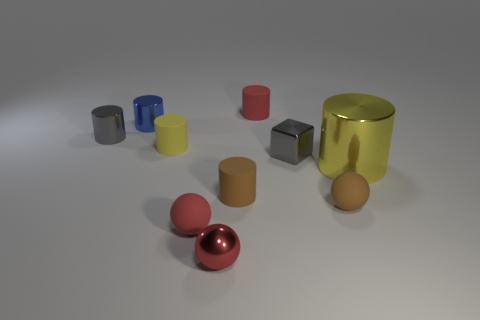Can you describe the textures and colors present in this collection of objects? The objects displayed in the image showcase a variety of textures and colors. Some objects have a shiny, metallic finish, reflecting light and providing a sense of smoothness. These include the red ball and the tiny ball next to it, as well as the yellow cylinder. Others, like the blue cylinder, exhibit a matte finish, suggesting a rougher, less reflective texture. As for colors, there's a vibrant palette with red, blue, yellow, and neutral tones like gray and beige. 